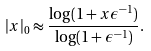Convert formula to latex. <formula><loc_0><loc_0><loc_500><loc_500>| x | _ { 0 } \approx \frac { \log ( 1 + x \epsilon ^ { - 1 } ) } { \log ( 1 + \epsilon ^ { - 1 } ) } .</formula> 